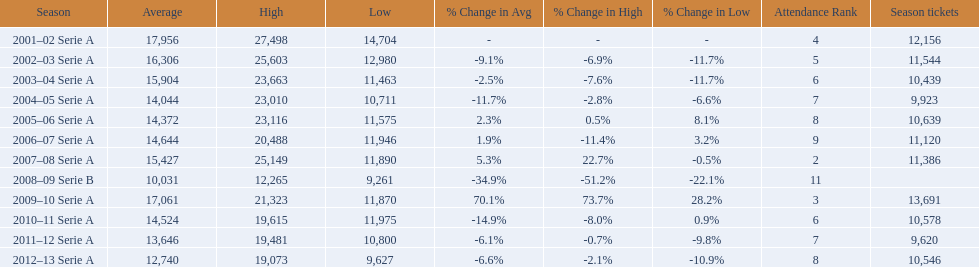What seasons were played at the stadio ennio tardini 2001–02 Serie A, 2002–03 Serie A, 2003–04 Serie A, 2004–05 Serie A, 2005–06 Serie A, 2006–07 Serie A, 2007–08 Serie A, 2008–09 Serie B, 2009–10 Serie A, 2010–11 Serie A, 2011–12 Serie A, 2012–13 Serie A. Which of these seasons had season tickets? 2001–02 Serie A, 2002–03 Serie A, 2003–04 Serie A, 2004–05 Serie A, 2005–06 Serie A, 2006–07 Serie A, 2007–08 Serie A, 2009–10 Serie A, 2010–11 Serie A, 2011–12 Serie A, 2012–13 Serie A. How many season tickets did the 2007-08 season have? 11,386. 